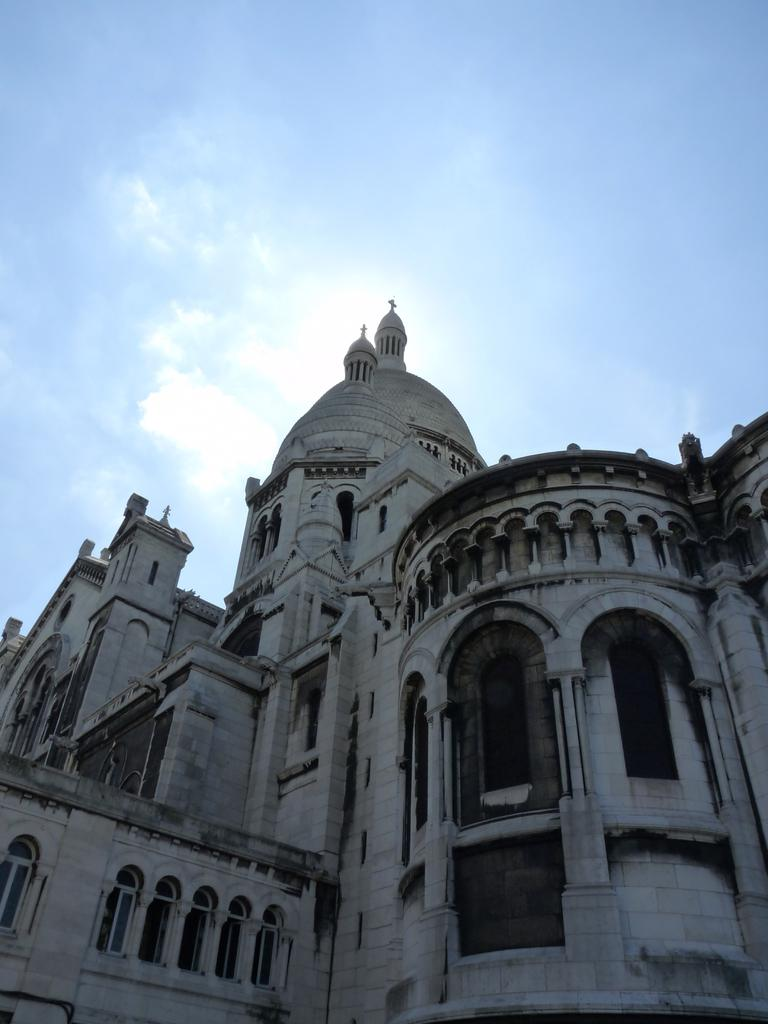What type of structure is present in the image? There is a building in the image. Where is the building located in relation to the image? The building is at the bottom of the image. What can be seen in the background of the image? The sky is visible in the background of the image. What type of education is being protested in the image? There is no indication of education or a protest in the image; it features a building and the sky. 